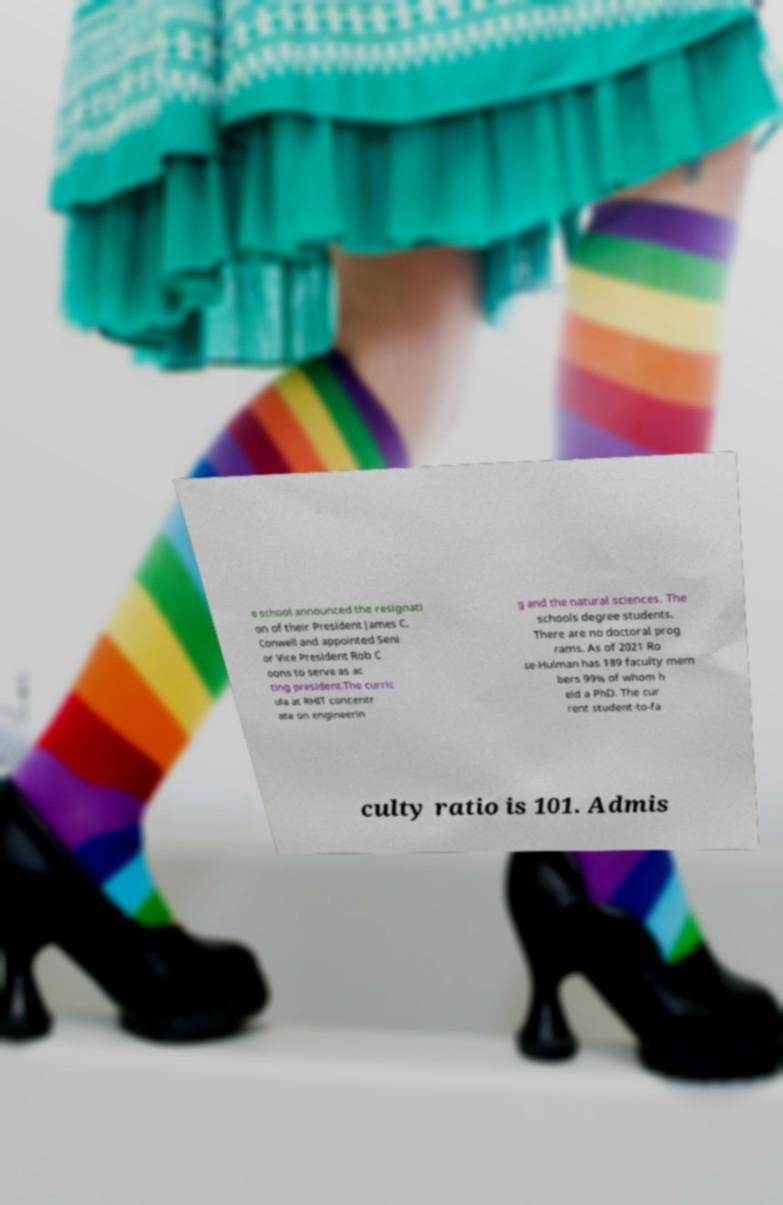Please identify and transcribe the text found in this image. e school announced the resignati on of their President James C. Conwell and appointed Seni or Vice President Rob C oons to serve as ac ting president.The curric ula at RHIT concentr ate on engineerin g and the natural sciences. The schools degree students. There are no doctoral prog rams. As of 2021 Ro se-Hulman has 189 faculty mem bers 99% of whom h eld a PhD. The cur rent student-to-fa culty ratio is 101. Admis 